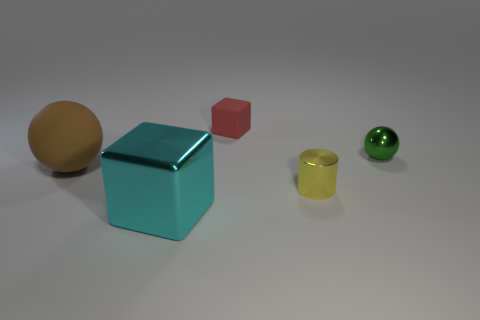How many other things are the same material as the tiny green thing?
Keep it short and to the point. 2. How many objects are either shiny things that are in front of the tiny green sphere or cubes on the right side of the cyan metallic cube?
Make the answer very short. 3. There is a large brown thing that is the same shape as the small green metallic thing; what is it made of?
Make the answer very short. Rubber. Are there any balls?
Your answer should be compact. Yes. There is a thing that is in front of the matte ball and on the left side of the tiny yellow thing; what is its size?
Offer a terse response. Large. There is a large metallic object; what shape is it?
Make the answer very short. Cube. Are there any big things behind the metallic thing that is in front of the small metal cylinder?
Provide a succinct answer. Yes. There is a block that is the same size as the yellow metallic object; what is its material?
Offer a very short reply. Rubber. Are there any yellow metal objects that have the same size as the green shiny object?
Make the answer very short. Yes. There is a small thing that is behind the green metal sphere; what is its material?
Offer a very short reply. Rubber. 